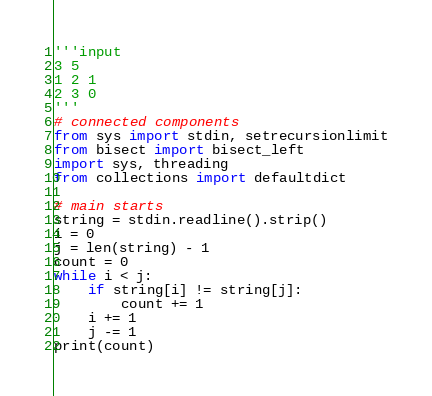<code> <loc_0><loc_0><loc_500><loc_500><_Python_>'''input
3 5
1 2 1
2 3 0
'''
# connected components
from sys import stdin, setrecursionlimit
from bisect import bisect_left
import sys, threading
from collections import defaultdict

# main starts
string = stdin.readline().strip()
i = 0
j = len(string) - 1
count = 0
while i < j:
    if string[i] != string[j]:
        count += 1
    i += 1
    j -= 1
print(count)</code> 